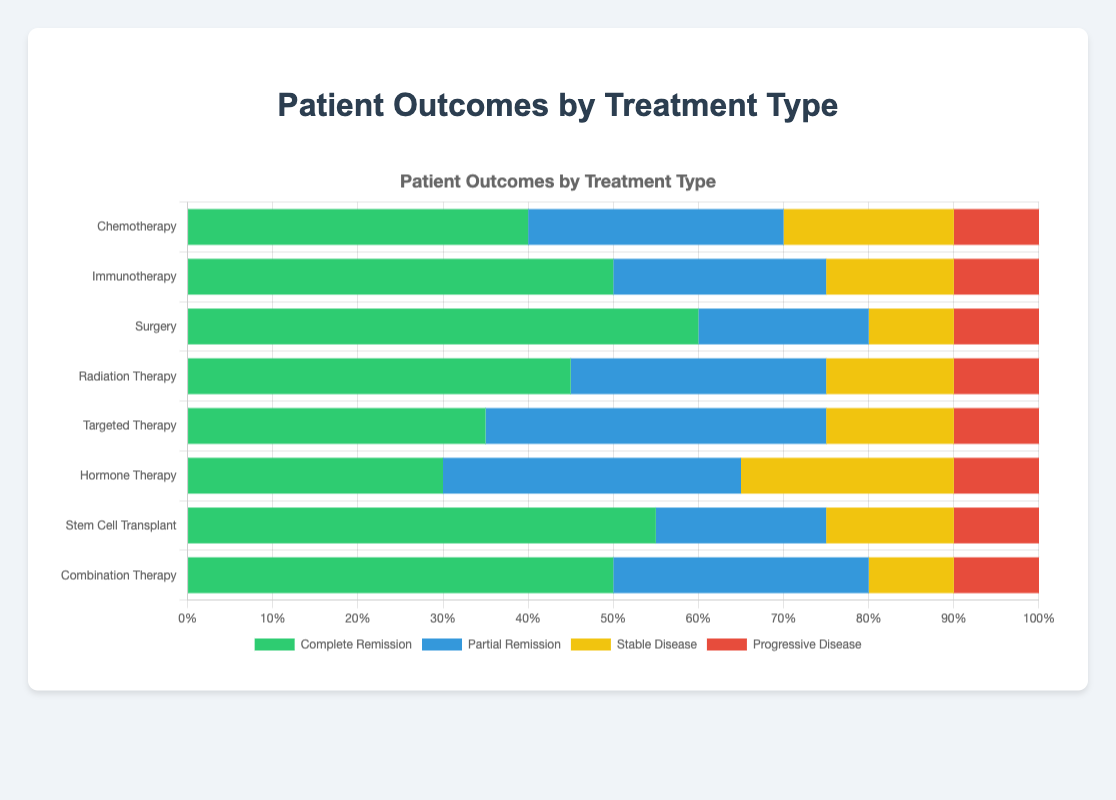What is the treatment type with the highest complete remission rate? First, locate the "Complete Remission" section in each bar. Then, compare the lengths of the green sections for all treatments. Surgery has the longest green section, indicating the highest complete remission rate at 60%.
Answer: Surgery Which treatment type has the lowest partial remission rate? Identify the "Partial Remission" sections by looking at the blue portions for each treatment type. Measure and compare the sizes. Surgery shows the smallest segment in blue, at 20%.
Answer: Surgery What is the combined percentage of stable and progressive disease outcomes for Targeted Therapy? Find and add the percentages of "Stable Disease" and "Progressive Disease" for Targeted Therapy. The yellow and red portions are 15% and 10%, respectively. Adding these together gives 15%+10%=25%.
Answer: 25% Between Chemotherapy and Radiation Therapy, which shows a higher rate of Partial Remission? Locate and compare the blue sections labeled "Partial Remission" for both treatments. Chemotherapy has a 30% rate, whereas Radiation Therapy also has a 30% rate. They are equal.
Answer: They are equal Which treatment type has the highest combined percentage of Complete and Partial Remission? For each treatment, sum the "Complete Remission" and "Partial Remission" percentages. Then, compare these combined values. Surgery has the highest sum (60%+20%=80%).
Answer: Surgery What is the difference in Complete Remission rates between Immunotherapy and Hormone Therapy? Subtract the "Complete Remission" percentage of Hormone Therapy (30%) from Immunotherapy (50%). Thus, 50%-30%=20%.
Answer: 20% Which treatment type has the equal percentages for all categories? Look for a treatment where all colors (green, blue, yellow, and red) occupy the same portion of the bar. No treatment type displays equal distribution among categories in the given data.
Answer: None How many treatment types have a Progressive Disease rate of 10%? Identify and count the red segments across all treatments. Every treatment type has a 10% rate for Progressive Disease. There are 8 treatment types in total.
Answer: 8 